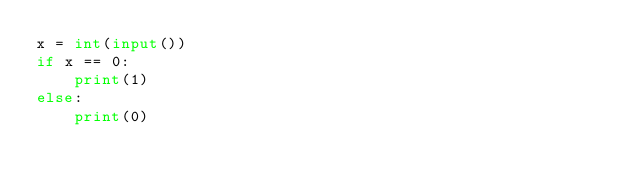<code> <loc_0><loc_0><loc_500><loc_500><_Python_>x = int(input())
if x == 0:
    print(1)
else:
    print(0)</code> 